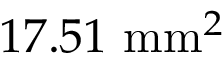<formula> <loc_0><loc_0><loc_500><loc_500>1 7 . 5 1 m m ^ { 2 }</formula> 